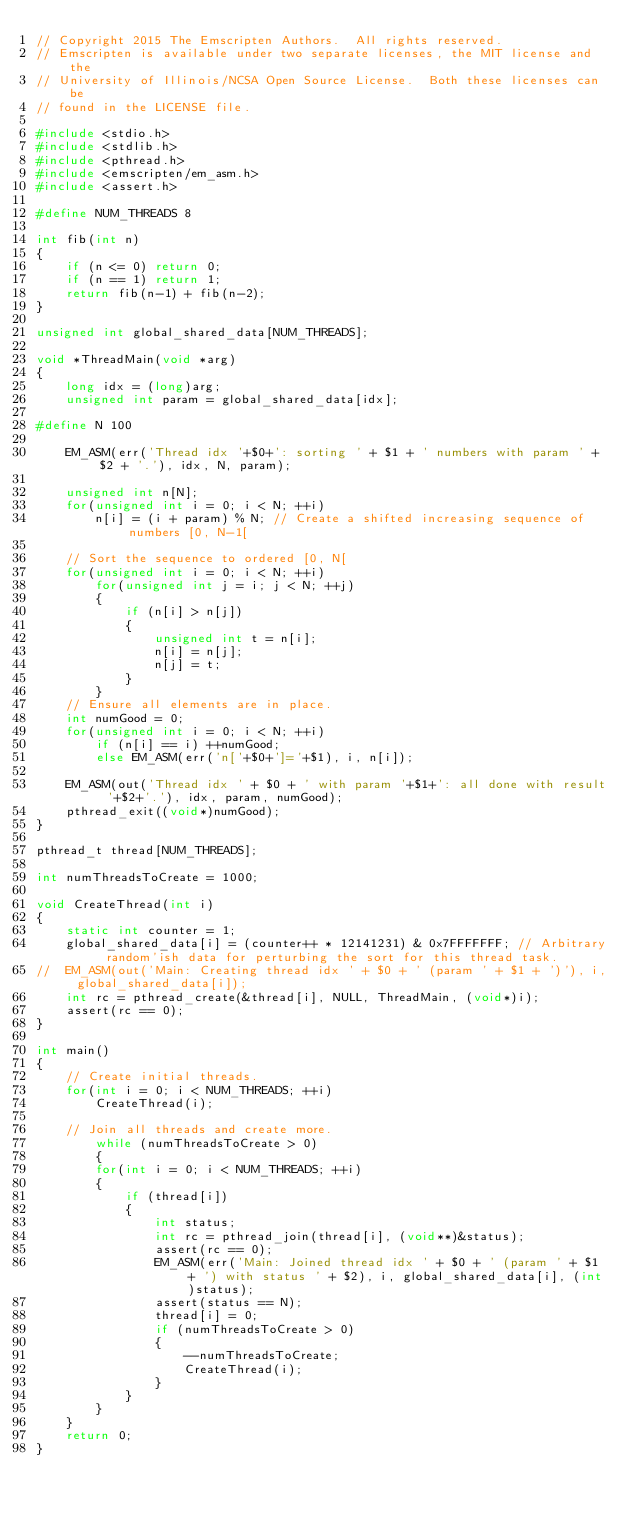Convert code to text. <code><loc_0><loc_0><loc_500><loc_500><_C++_>// Copyright 2015 The Emscripten Authors.  All rights reserved.
// Emscripten is available under two separate licenses, the MIT license and the
// University of Illinois/NCSA Open Source License.  Both these licenses can be
// found in the LICENSE file.

#include <stdio.h>
#include <stdlib.h>
#include <pthread.h>
#include <emscripten/em_asm.h>
#include <assert.h>

#define NUM_THREADS 8

int fib(int n)
{
	if (n <= 0) return 0;
	if (n == 1) return 1;
	return fib(n-1) + fib(n-2);
}

unsigned int global_shared_data[NUM_THREADS];

void *ThreadMain(void *arg)
{
	long idx = (long)arg;
	unsigned int param = global_shared_data[idx];

#define N 100

	EM_ASM(err('Thread idx '+$0+': sorting ' + $1 + ' numbers with param ' + $2 + '.'), idx, N, param);

	unsigned int n[N];
	for(unsigned int i = 0; i < N; ++i)
		n[i] = (i + param) % N; // Create a shifted increasing sequence of numbers [0, N-1[

	// Sort the sequence to ordered [0, N[
	for(unsigned int i = 0; i < N; ++i)
		for(unsigned int j = i; j < N; ++j)
		{
			if (n[i] > n[j])
			{
				unsigned int t = n[i];
				n[i] = n[j];
				n[j] = t;
			}
		}
	// Ensure all elements are in place.
	int numGood = 0;
	for(unsigned int i = 0; i < N; ++i)
		if (n[i] == i) ++numGood;
		else EM_ASM(err('n['+$0+']='+$1), i, n[i]);

	EM_ASM(out('Thread idx ' + $0 + ' with param '+$1+': all done with result '+$2+'.'), idx, param, numGood);
	pthread_exit((void*)numGood);
}

pthread_t thread[NUM_THREADS];

int numThreadsToCreate = 1000;

void CreateThread(int i)
{
	static int counter = 1;
	global_shared_data[i] = (counter++ * 12141231) & 0x7FFFFFFF; // Arbitrary random'ish data for perturbing the sort for this thread task.
//	EM_ASM(out('Main: Creating thread idx ' + $0 + ' (param ' + $1 + ')'), i, global_shared_data[i]);
	int rc = pthread_create(&thread[i], NULL, ThreadMain, (void*)i);
	assert(rc == 0);
}

int main()
{
	// Create initial threads.
	for(int i = 0; i < NUM_THREADS; ++i)
		CreateThread(i);

	// Join all threads and create more.
        while (numThreadsToCreate > 0)
        {
		for(int i = 0; i < NUM_THREADS; ++i)
		{
			if (thread[i])
			{
				int status;
				int rc = pthread_join(thread[i], (void**)&status);
				assert(rc == 0);
				EM_ASM(err('Main: Joined thread idx ' + $0 + ' (param ' + $1 + ') with status ' + $2), i, global_shared_data[i], (int)status);
				assert(status == N);
				thread[i] = 0;
				if (numThreadsToCreate > 0)
				{
					--numThreadsToCreate;
					CreateThread(i);
				}
			}
		}
	}
	return 0;
}
</code> 